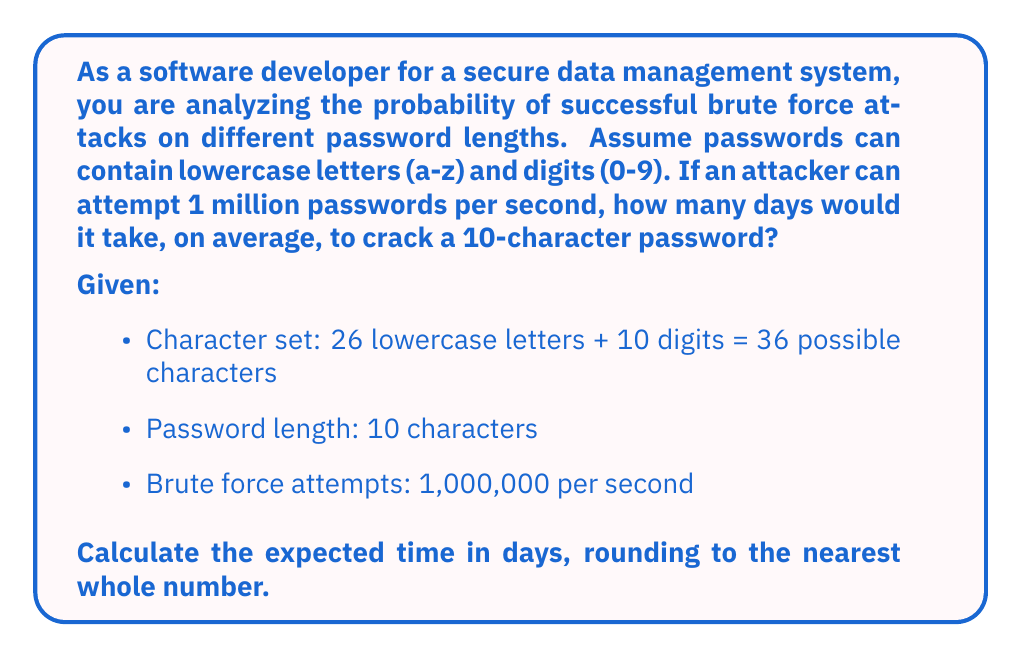Teach me how to tackle this problem. To solve this problem, we need to follow these steps:

1. Calculate the total number of possible passwords:
   With 36 possible characters and a length of 10, the total number of combinations is:
   $$ N = 36^{10} $$

2. Calculate the expected number of attempts:
   On average, an attacker would need to try half of all possible combinations:
   $$ E(\text{attempts}) = \frac{36^{10}}{2} $$

3. Calculate the time needed in seconds:
   $$ \text{Time (seconds)} = \frac{E(\text{attempts})}{\text{Attempts per second}} = \frac{36^{10}}{2 \times 1,000,000} $$

4. Convert seconds to days:
   $$ \text{Time (days)} = \frac{\text{Time (seconds)}}{86400} $$

Now, let's perform the calculations:

1. $N = 36^{10} = 3,656,158,440,062,976$

2. $E(\text{attempts}) = \frac{3,656,158,440,062,976}{2} = 1,828,079,220,031,488$

3. $\text{Time (seconds)} = \frac{1,828,079,220,031,488}{1,000,000} = 1,828,079,220$

4. $\text{Time (days)} = \frac{1,828,079,220}{86400} \approx 21,158.32$

Rounding to the nearest whole number, we get 21,158 days.
Answer: 21,158 days 